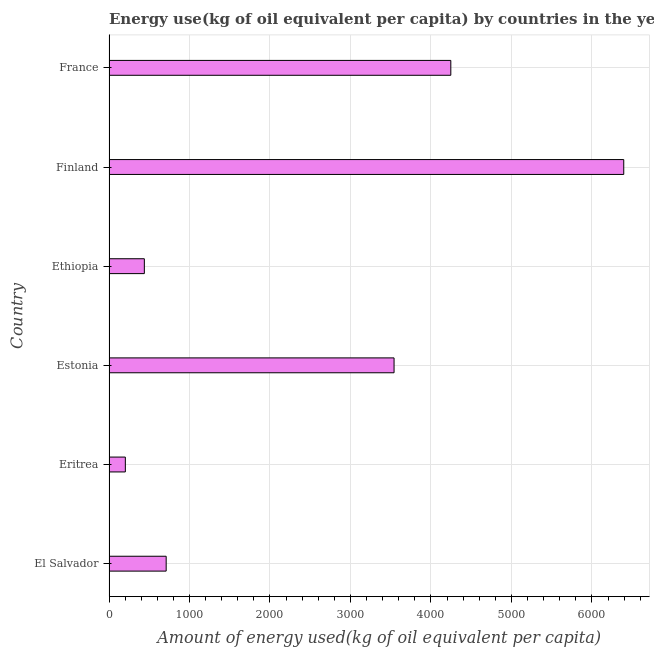Does the graph contain any zero values?
Your response must be concise. No. What is the title of the graph?
Your answer should be very brief. Energy use(kg of oil equivalent per capita) by countries in the year 2001. What is the label or title of the X-axis?
Keep it short and to the point. Amount of energy used(kg of oil equivalent per capita). What is the label or title of the Y-axis?
Give a very brief answer. Country. What is the amount of energy used in Eritrea?
Provide a succinct answer. 202.93. Across all countries, what is the maximum amount of energy used?
Keep it short and to the point. 6395.27. Across all countries, what is the minimum amount of energy used?
Offer a very short reply. 202.93. In which country was the amount of energy used maximum?
Provide a succinct answer. Finland. In which country was the amount of energy used minimum?
Your answer should be compact. Eritrea. What is the sum of the amount of energy used?
Ensure brevity in your answer.  1.55e+04. What is the difference between the amount of energy used in Estonia and France?
Your answer should be very brief. -705.01. What is the average amount of energy used per country?
Offer a very short reply. 2589.22. What is the median amount of energy used?
Give a very brief answer. 2125.82. In how many countries, is the amount of energy used greater than 5200 kg?
Your answer should be compact. 1. What is the ratio of the amount of energy used in Finland to that in France?
Your answer should be compact. 1.51. Is the amount of energy used in Ethiopia less than that in France?
Provide a short and direct response. Yes. What is the difference between the highest and the second highest amount of energy used?
Give a very brief answer. 2148.76. What is the difference between the highest and the lowest amount of energy used?
Your response must be concise. 6192.34. How many bars are there?
Your answer should be very brief. 6. Are all the bars in the graph horizontal?
Offer a terse response. Yes. How many countries are there in the graph?
Make the answer very short. 6. What is the Amount of energy used(kg of oil equivalent per capita) of El Salvador?
Ensure brevity in your answer.  710.12. What is the Amount of energy used(kg of oil equivalent per capita) in Eritrea?
Offer a very short reply. 202.93. What is the Amount of energy used(kg of oil equivalent per capita) in Estonia?
Give a very brief answer. 3541.51. What is the Amount of energy used(kg of oil equivalent per capita) of Ethiopia?
Your response must be concise. 438.96. What is the Amount of energy used(kg of oil equivalent per capita) in Finland?
Make the answer very short. 6395.27. What is the Amount of energy used(kg of oil equivalent per capita) of France?
Provide a short and direct response. 4246.52. What is the difference between the Amount of energy used(kg of oil equivalent per capita) in El Salvador and Eritrea?
Your response must be concise. 507.18. What is the difference between the Amount of energy used(kg of oil equivalent per capita) in El Salvador and Estonia?
Your answer should be compact. -2831.39. What is the difference between the Amount of energy used(kg of oil equivalent per capita) in El Salvador and Ethiopia?
Your answer should be very brief. 271.16. What is the difference between the Amount of energy used(kg of oil equivalent per capita) in El Salvador and Finland?
Provide a short and direct response. -5685.16. What is the difference between the Amount of energy used(kg of oil equivalent per capita) in El Salvador and France?
Ensure brevity in your answer.  -3536.4. What is the difference between the Amount of energy used(kg of oil equivalent per capita) in Eritrea and Estonia?
Keep it short and to the point. -3338.58. What is the difference between the Amount of energy used(kg of oil equivalent per capita) in Eritrea and Ethiopia?
Your answer should be very brief. -236.02. What is the difference between the Amount of energy used(kg of oil equivalent per capita) in Eritrea and Finland?
Your answer should be compact. -6192.34. What is the difference between the Amount of energy used(kg of oil equivalent per capita) in Eritrea and France?
Ensure brevity in your answer.  -4043.58. What is the difference between the Amount of energy used(kg of oil equivalent per capita) in Estonia and Ethiopia?
Offer a very short reply. 3102.55. What is the difference between the Amount of energy used(kg of oil equivalent per capita) in Estonia and Finland?
Give a very brief answer. -2853.76. What is the difference between the Amount of energy used(kg of oil equivalent per capita) in Estonia and France?
Provide a succinct answer. -705.01. What is the difference between the Amount of energy used(kg of oil equivalent per capita) in Ethiopia and Finland?
Provide a short and direct response. -5956.32. What is the difference between the Amount of energy used(kg of oil equivalent per capita) in Ethiopia and France?
Provide a succinct answer. -3807.56. What is the difference between the Amount of energy used(kg of oil equivalent per capita) in Finland and France?
Your answer should be compact. 2148.76. What is the ratio of the Amount of energy used(kg of oil equivalent per capita) in El Salvador to that in Eritrea?
Ensure brevity in your answer.  3.5. What is the ratio of the Amount of energy used(kg of oil equivalent per capita) in El Salvador to that in Estonia?
Provide a short and direct response. 0.2. What is the ratio of the Amount of energy used(kg of oil equivalent per capita) in El Salvador to that in Ethiopia?
Provide a short and direct response. 1.62. What is the ratio of the Amount of energy used(kg of oil equivalent per capita) in El Salvador to that in Finland?
Offer a terse response. 0.11. What is the ratio of the Amount of energy used(kg of oil equivalent per capita) in El Salvador to that in France?
Provide a succinct answer. 0.17. What is the ratio of the Amount of energy used(kg of oil equivalent per capita) in Eritrea to that in Estonia?
Keep it short and to the point. 0.06. What is the ratio of the Amount of energy used(kg of oil equivalent per capita) in Eritrea to that in Ethiopia?
Offer a terse response. 0.46. What is the ratio of the Amount of energy used(kg of oil equivalent per capita) in Eritrea to that in Finland?
Make the answer very short. 0.03. What is the ratio of the Amount of energy used(kg of oil equivalent per capita) in Eritrea to that in France?
Give a very brief answer. 0.05. What is the ratio of the Amount of energy used(kg of oil equivalent per capita) in Estonia to that in Ethiopia?
Keep it short and to the point. 8.07. What is the ratio of the Amount of energy used(kg of oil equivalent per capita) in Estonia to that in Finland?
Ensure brevity in your answer.  0.55. What is the ratio of the Amount of energy used(kg of oil equivalent per capita) in Estonia to that in France?
Provide a succinct answer. 0.83. What is the ratio of the Amount of energy used(kg of oil equivalent per capita) in Ethiopia to that in Finland?
Ensure brevity in your answer.  0.07. What is the ratio of the Amount of energy used(kg of oil equivalent per capita) in Ethiopia to that in France?
Offer a very short reply. 0.1. What is the ratio of the Amount of energy used(kg of oil equivalent per capita) in Finland to that in France?
Provide a succinct answer. 1.51. 